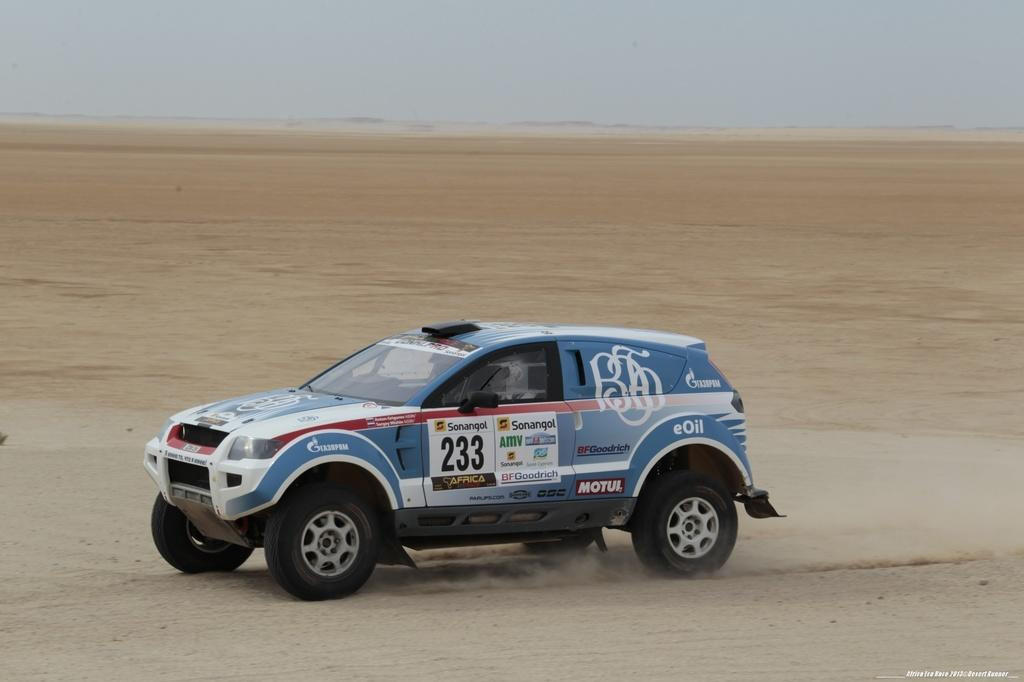What is the main subject in the center of the image? There is a vehicle in the center of the image. What can be seen below the vehicle in the image? The ground is visible at the bottom of the image. What is visible above the vehicle in the image? The sky is visible at the top of the image. Where is the goat guiding the vehicle in the image? There is no goat present in the image, and therefore no guiding of the vehicle is taking place. 